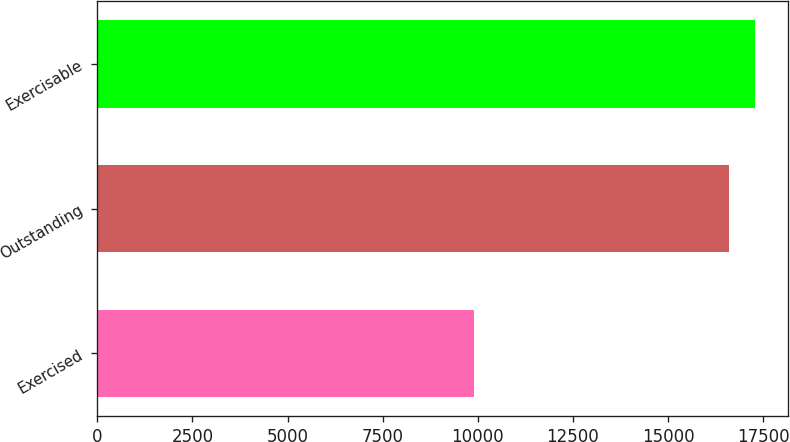Convert chart to OTSL. <chart><loc_0><loc_0><loc_500><loc_500><bar_chart><fcel>Exercised<fcel>Outstanding<fcel>Exercisable<nl><fcel>9890<fcel>16605<fcel>17276.5<nl></chart> 